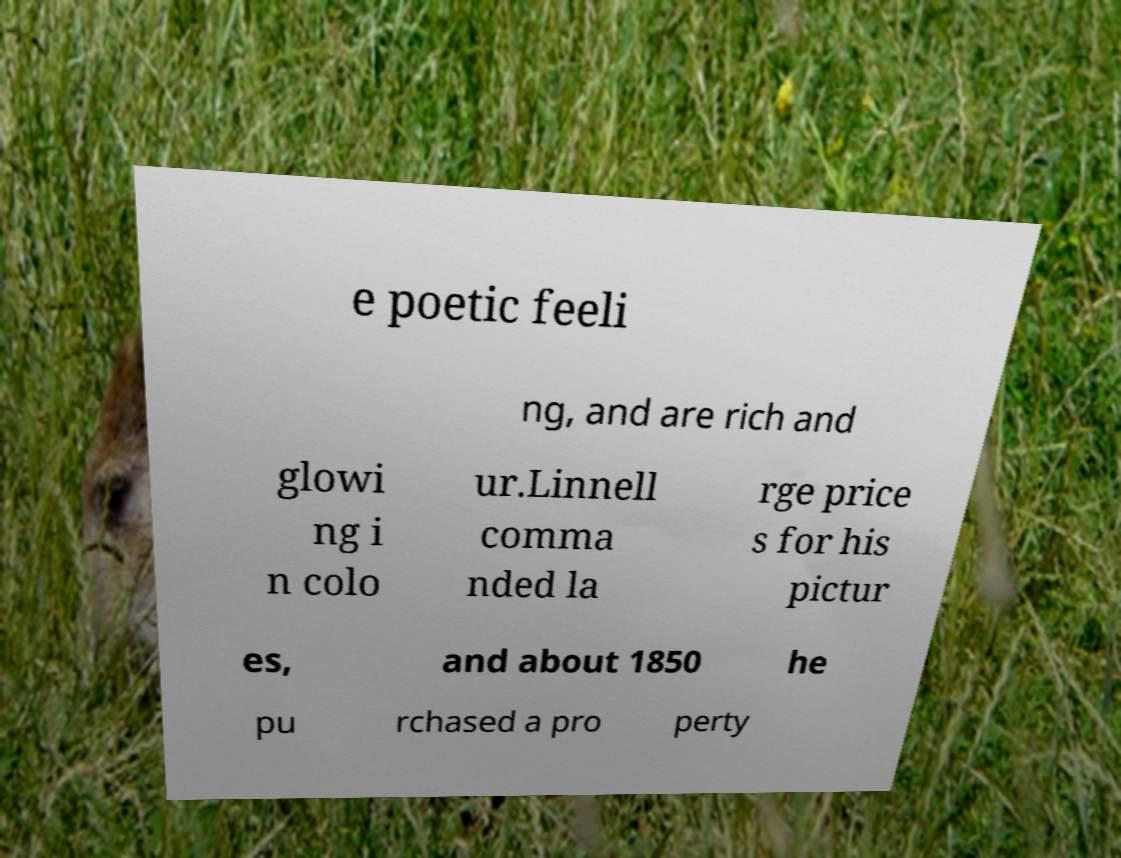Please read and relay the text visible in this image. What does it say? e poetic feeli ng, and are rich and glowi ng i n colo ur.Linnell comma nded la rge price s for his pictur es, and about 1850 he pu rchased a pro perty 